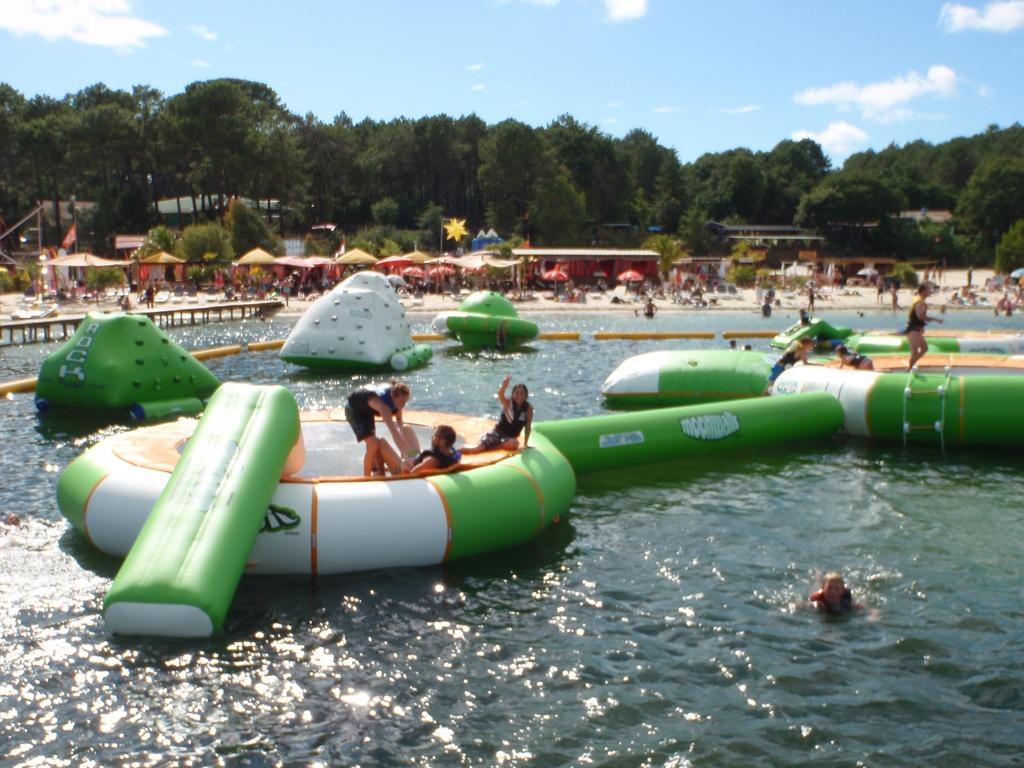In one or two sentences, can you explain what this image depicts? In this image we can see people sitting on the swimming tubes, children swimming in the water, parasols, walkway bridge, people lying on the seashore, buildings, trees and sky with clouds. 